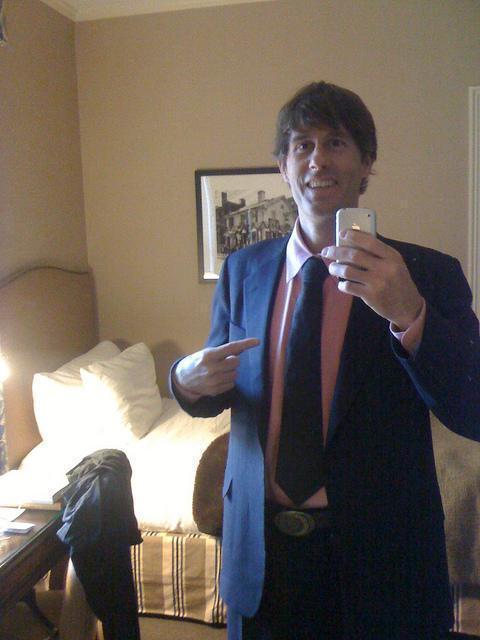What is the man doing?
From the following set of four choices, select the accurate answer to respond to the question.
Options: Running, sleeping, pointing, eating. Pointing. 